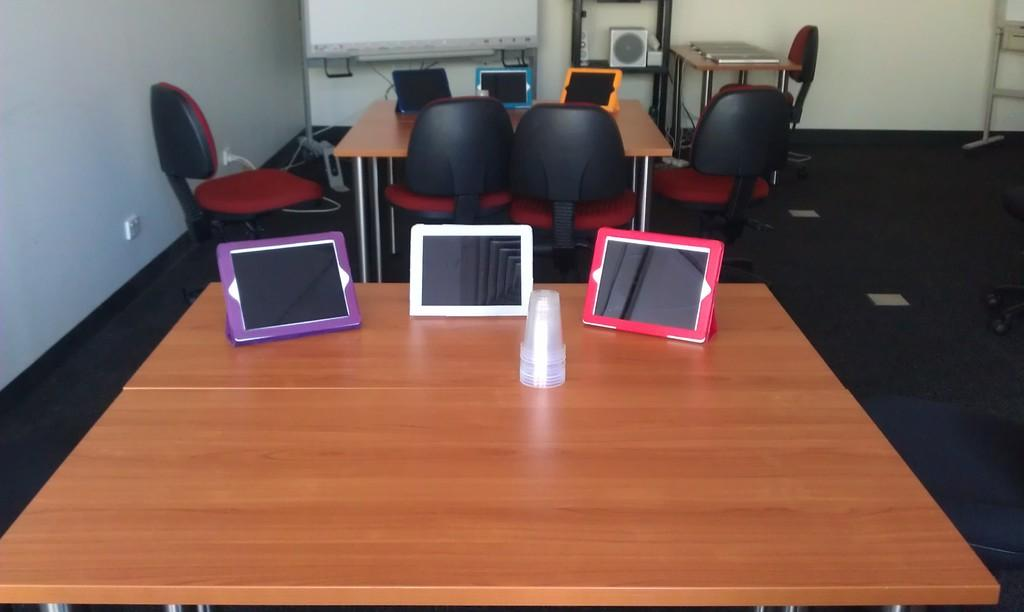What electronic devices are on the table in the image? There are Ipads on the table in the image. What type of furniture is located at the back side of the image? There are chairs at the back side of the image. What is the large, rectangular object visible at the top of the image? There is a projector screen visible at the top of the image. Where is the sink located in the image? There is no sink present in the image. What level of the building is the image taken from? The facts provided do not give any information about the level of the building, so we cannot determine the level from the image. 